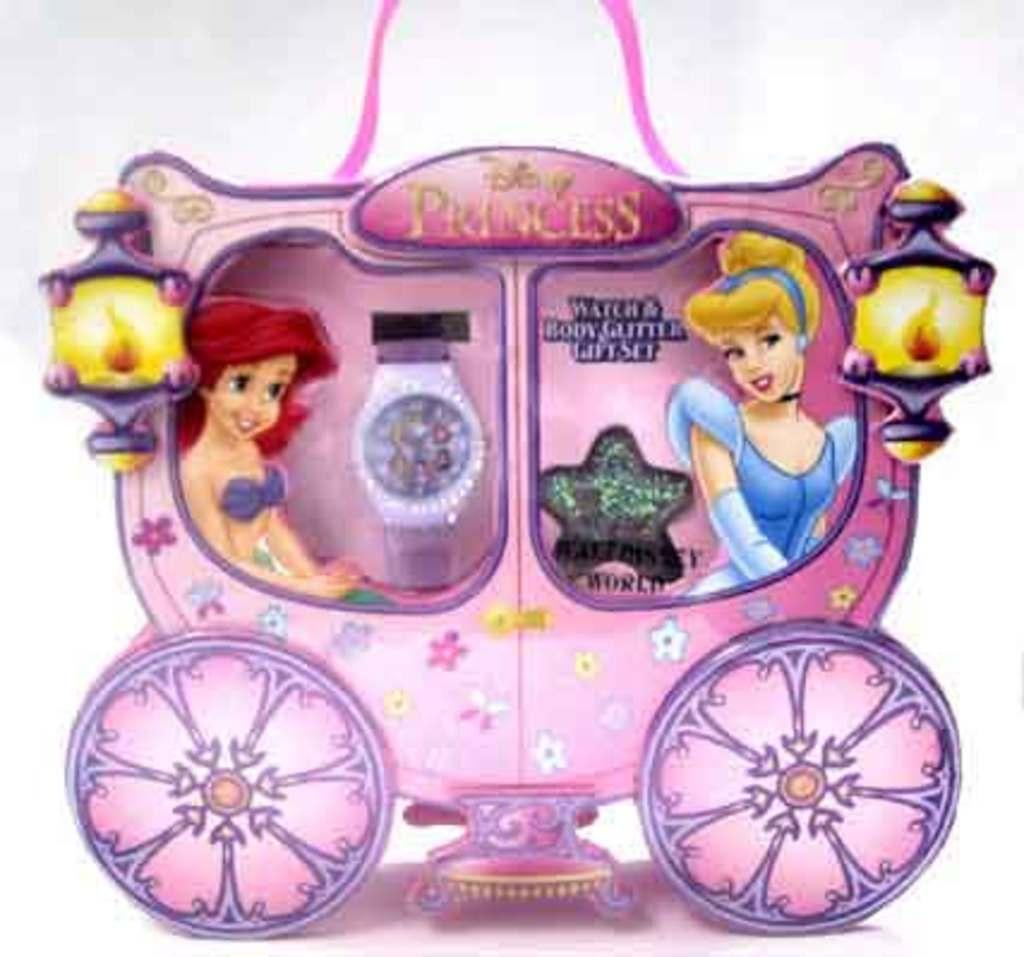<image>
Describe the image concisely. A girl's toy for Disney PRINCESS dolls with Cinderella and Ariel. 